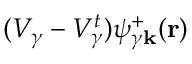Convert formula to latex. <formula><loc_0><loc_0><loc_500><loc_500>( V _ { \gamma } - V _ { \gamma } ^ { t } ) \psi _ { \gamma k } ^ { + } ( r )</formula> 